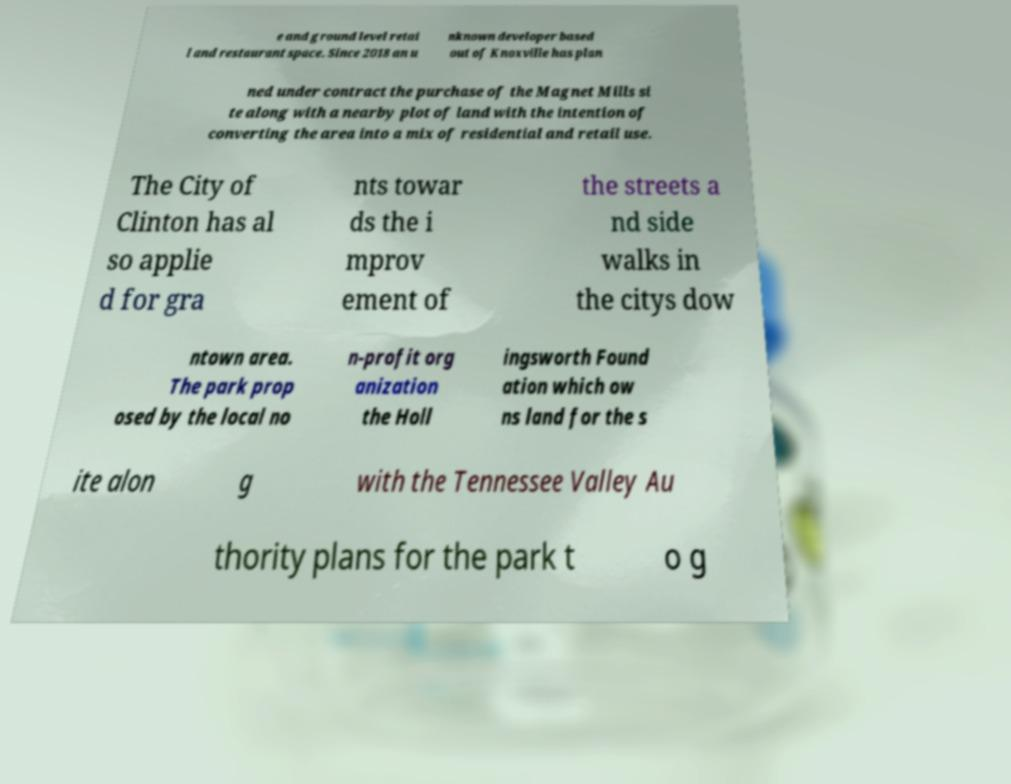What messages or text are displayed in this image? I need them in a readable, typed format. e and ground level retai l and restaurant space. Since 2018 an u nknown developer based out of Knoxville has plan ned under contract the purchase of the Magnet Mills si te along with a nearby plot of land with the intention of converting the area into a mix of residential and retail use. The City of Clinton has al so applie d for gra nts towar ds the i mprov ement of the streets a nd side walks in the citys dow ntown area. The park prop osed by the local no n-profit org anization the Holl ingsworth Found ation which ow ns land for the s ite alon g with the Tennessee Valley Au thority plans for the park t o g 